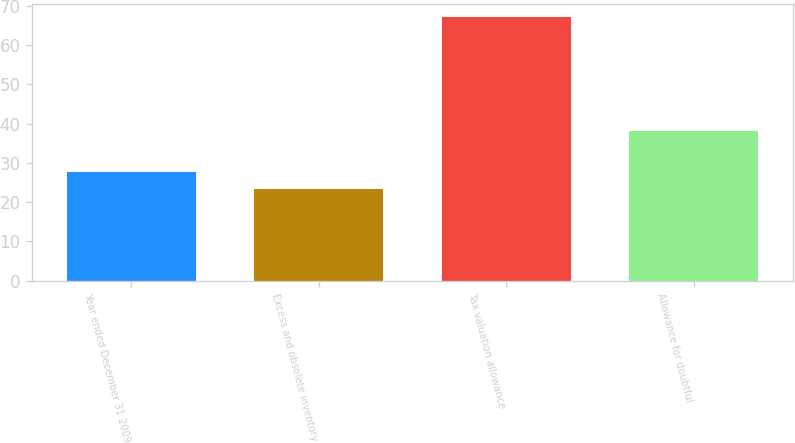Convert chart. <chart><loc_0><loc_0><loc_500><loc_500><bar_chart><fcel>Year ended December 31 2009<fcel>Excess and obsolete inventory<fcel>Tax valuation allowance<fcel>Allowance for doubtful<nl><fcel>27.76<fcel>23.4<fcel>67<fcel>38.2<nl></chart> 